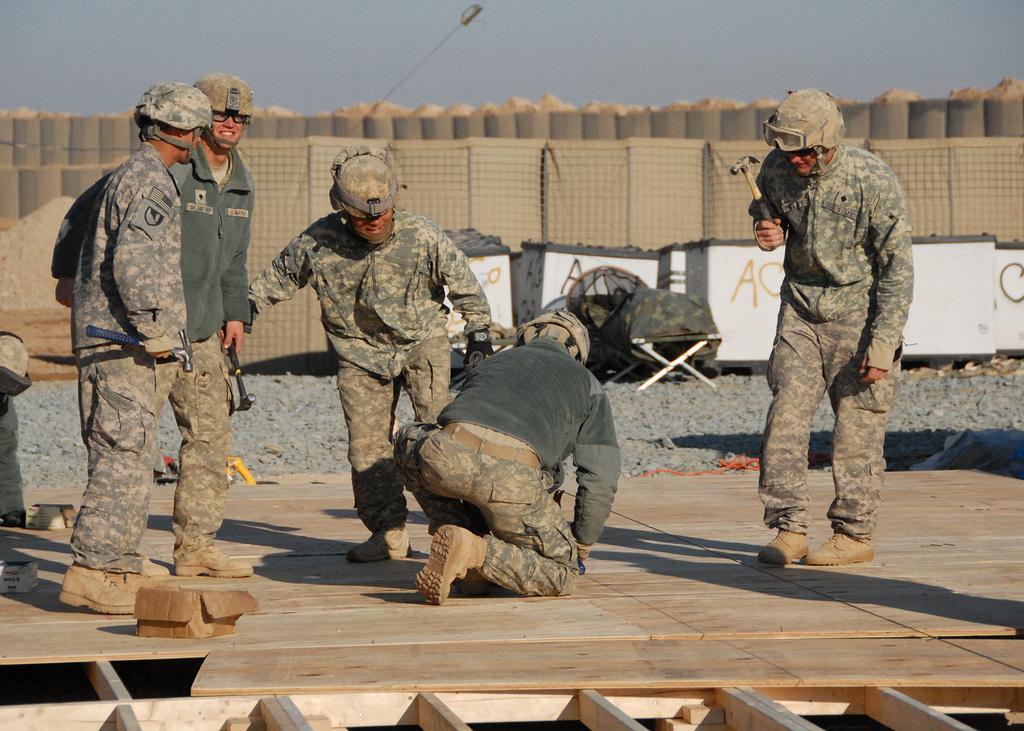In one or two sentences, can you explain what this image depicts? In this image in the foreground there are four persons, holding hammer, standing, one person sitting in squat position, all are visible on wooden plank, behind them there is a concrete, white color container, soil, fence, light poles, some other objects visible, at the top there is the sky. 